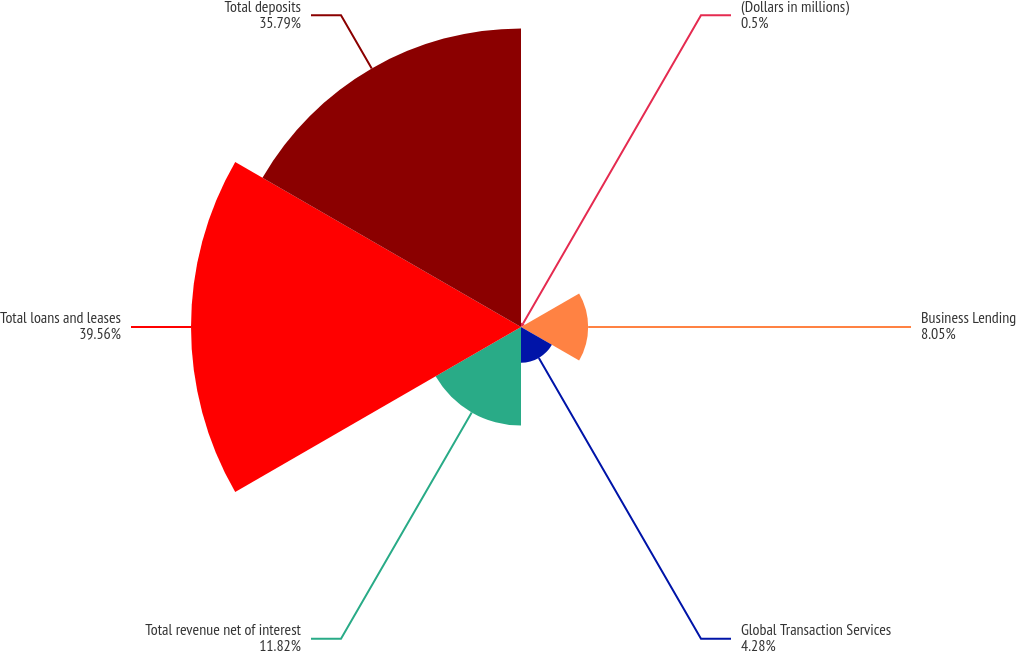Convert chart. <chart><loc_0><loc_0><loc_500><loc_500><pie_chart><fcel>(Dollars in millions)<fcel>Business Lending<fcel>Global Transaction Services<fcel>Total revenue net of interest<fcel>Total loans and leases<fcel>Total deposits<nl><fcel>0.5%<fcel>8.05%<fcel>4.28%<fcel>11.82%<fcel>39.56%<fcel>35.79%<nl></chart> 